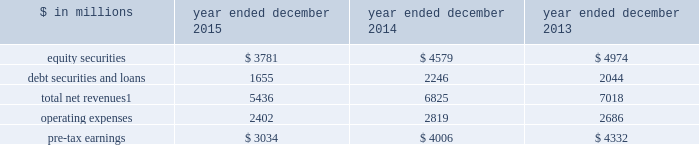The goldman sachs group , inc .
And subsidiaries management 2019s discussion and analysis investing & lending investing & lending includes our investing activities and the origination of loans to provide financing to clients .
These investments and loans are typically longer-term in nature .
We make investments , some of which are consolidated , directly and indirectly through funds and separate accounts that we manage , in debt securities and loans , public and private equity securities , and real estate entities .
The table below presents the operating results of our investing & lending segment. .
Net revenues related to our consolidated investments , previously reported in other net revenues within investing & lending , are now reported in equity securities and debt securities and loans , as results from these activities ( $ 391 million for 2015 ) are no longer significant principally due to the sale of metro in the fourth quarter of 2014 .
Reclassifications have been made to previously reported amounts to conform to the current presentation .
2015 versus 2014 .
Net revenues in investing & lending were $ 5.44 billion for 2015 , 20% ( 20 % ) lower than 2014 .
This decrease was primarily due to lower net revenues from investments in equities , principally reflecting the sale of metro in the fourth quarter of 2014 and lower net gains from investments in private equities , driven by corporate performance .
In addition , net revenues in debt securities and loans were significantly lower , reflecting lower net gains from investments .
Although net revenues in investing & lending for 2015 benefited from favorable company-specific events , including sales , initial public offerings and financings , a decline in global equity prices and widening high-yield credit spreads during the second half of the year impacted results .
Concern about the outlook for the global economy continues to be a meaningful consideration for the global marketplace .
If equity markets continue to decline or credit spreads widen further , net revenues in investing & lending would likely continue to be negatively impacted .
Operating expenses were $ 2.40 billion for 2015 , 15% ( 15 % ) lower than 2014 , due to lower depreciation and amortization expenses , primarily reflecting lower impairment charges related to consolidated investments , and a reduction in expenses related to the sale of metro in the fourth quarter of 2014 .
Pre-tax earnings were $ 3.03 billion in 2015 , 24% ( 24 % ) lower than 2014 .
2014 versus 2013 .
Net revenues in investing & lending were $ 6.83 billion for 2014 , 3% ( 3 % ) lower than 2013 .
Net revenues from investments in equity securities were lower due to a significant decrease in net gains from investments in public equities , as movements in global equity prices during 2014 were less favorable compared with 2013 , as well as significantly lower net revenues related to our consolidated investments , reflecting a decrease in operating revenues from commodities-related consolidated investments .
These decreases were partially offset by an increase in net gains from investments in private equities , primarily driven by company-specific events .
Net revenues from debt securities and loans were higher than 2013 , reflecting a significant increase in net interest income , primarily driven by increased lending , and a slight increase in net gains , primarily due to sales of certain investments during 2014 .
During 2014 , net revenues in investing & lending generally reflected favorable company-specific events , including initial public offerings and financings , and strong corporate performance , as well as net gains from sales of certain investments .
Operating expenses were $ 2.82 billion for 2014 , 5% ( 5 % ) higher than 2013 , reflecting higher compensation and benefits expenses , partially offset by lower expenses related to consolidated investments .
Pre-tax earnings were $ 4.01 billion in 2014 , 8% ( 8 % ) lower than 2013 .
64 goldman sachs 2015 form 10-k .
What percentage of total net revenues in the investing & lending segment is attributable to equity securities in 2015? 
Computations: (3781 / 5436)
Answer: 0.69555. 